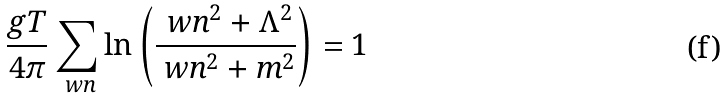<formula> <loc_0><loc_0><loc_500><loc_500>\frac { g T } { 4 \pi } \sum _ { \ w n } \ln \left ( \frac { \ w n ^ { 2 } + \Lambda ^ { 2 } } { \ w n ^ { 2 } + m ^ { 2 } } \right ) = 1</formula> 